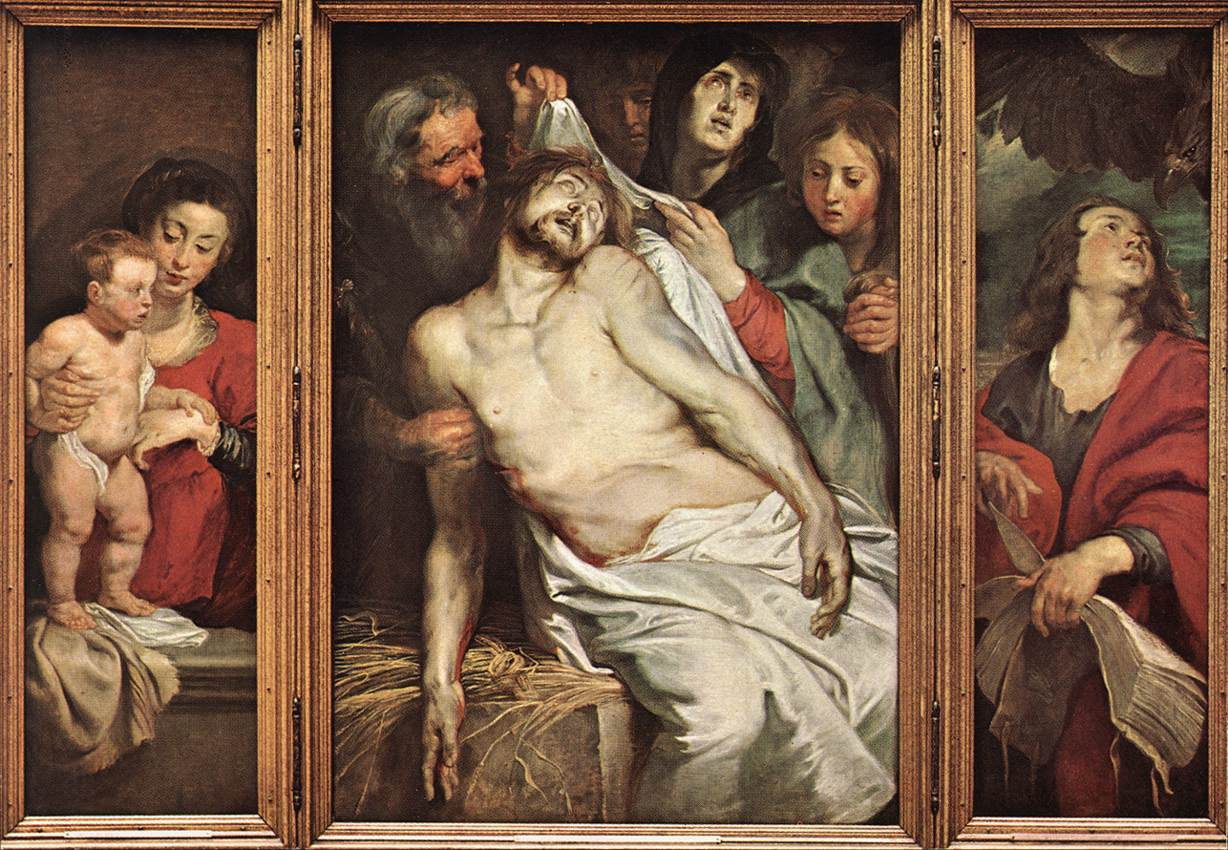Can you discuss the artistic techniques used in this painting and their effect on the viewer? The artist employs several Renaissance techniques to evoke a powerful emotional response. The use of chiaroscuro, the contrast between light and dark, highlights the central figure of Jesus, drawing the viewer’s focus immediately. The realistic depiction of human emotion in the mourners' faces enhances the painting's impact, making the scene relatable and poignant. The triptych structure not only adds a formal symmetry but also encapsulates the narrative in a way that guides the viewer through the story visually and spiritually. These techniques work collectively to not only showcase artistic mastery but also to deepen the viewer's engagement with the biblical narrative. 